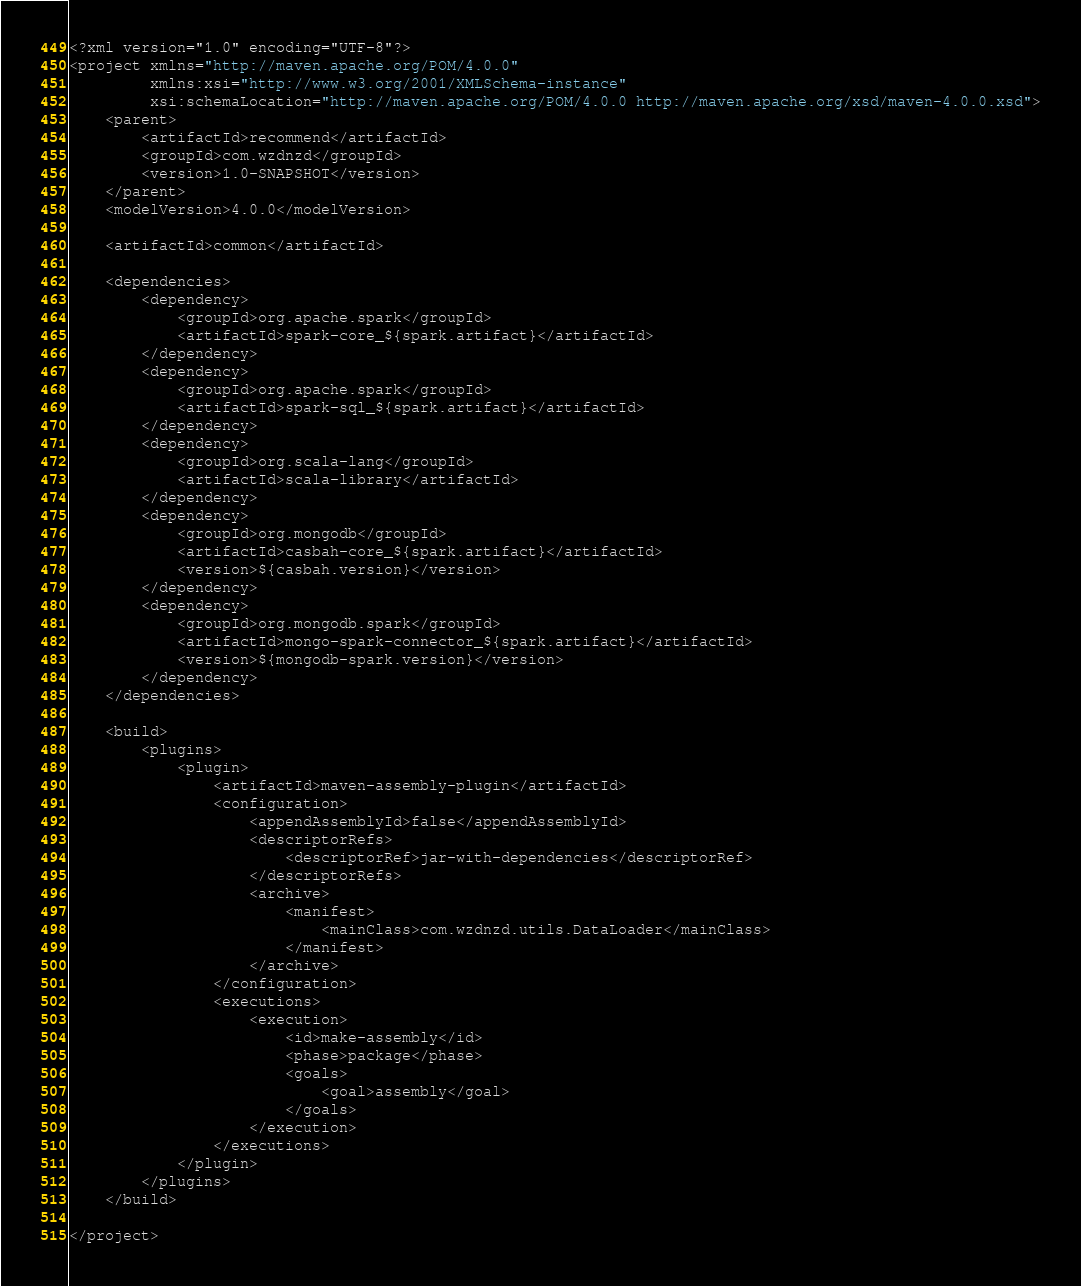Convert code to text. <code><loc_0><loc_0><loc_500><loc_500><_XML_><?xml version="1.0" encoding="UTF-8"?>
<project xmlns="http://maven.apache.org/POM/4.0.0"
         xmlns:xsi="http://www.w3.org/2001/XMLSchema-instance"
         xsi:schemaLocation="http://maven.apache.org/POM/4.0.0 http://maven.apache.org/xsd/maven-4.0.0.xsd">
    <parent>
        <artifactId>recommend</artifactId>
        <groupId>com.wzdnzd</groupId>
        <version>1.0-SNAPSHOT</version>
    </parent>
    <modelVersion>4.0.0</modelVersion>

    <artifactId>common</artifactId>

    <dependencies>
        <dependency>
            <groupId>org.apache.spark</groupId>
            <artifactId>spark-core_${spark.artifact}</artifactId>
        </dependency>
        <dependency>
            <groupId>org.apache.spark</groupId>
            <artifactId>spark-sql_${spark.artifact}</artifactId>
        </dependency>
        <dependency>
            <groupId>org.scala-lang</groupId>
            <artifactId>scala-library</artifactId>
        </dependency>
        <dependency>
            <groupId>org.mongodb</groupId>
            <artifactId>casbah-core_${spark.artifact}</artifactId>
            <version>${casbah.version}</version>
        </dependency>
        <dependency>
            <groupId>org.mongodb.spark</groupId>
            <artifactId>mongo-spark-connector_${spark.artifact}</artifactId>
            <version>${mongodb-spark.version}</version>
        </dependency>
    </dependencies>

    <build>
        <plugins>
            <plugin>
                <artifactId>maven-assembly-plugin</artifactId>
                <configuration>
                    <appendAssemblyId>false</appendAssemblyId>
                    <descriptorRefs>
                        <descriptorRef>jar-with-dependencies</descriptorRef>
                    </descriptorRefs>
                    <archive>
                        <manifest>
                            <mainClass>com.wzdnzd.utils.DataLoader</mainClass>
                        </manifest>
                    </archive>
                </configuration>
                <executions>
                    <execution>
                        <id>make-assembly</id>
                        <phase>package</phase>
                        <goals>
                            <goal>assembly</goal>
                        </goals>
                    </execution>
                </executions>
            </plugin>
        </plugins>
    </build>

</project></code> 